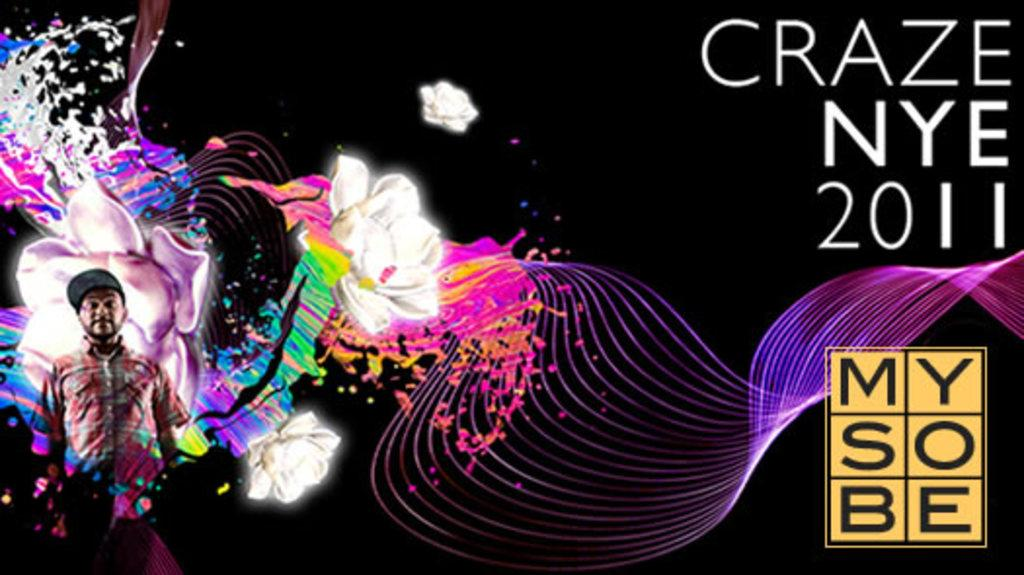What is located on the left side of the image? There is a person standing on the left side of the image. Can you describe the person's position or stance? The provided facts do not give information about the person's position or stance. Is there anyone else visible in the image besides the person on the left side? The provided facts do not mention any other people in the image. What type of respect can be seen on the tray in the image? There is no tray present in the image, so it is not possible to determine what type of respect might be on it. 